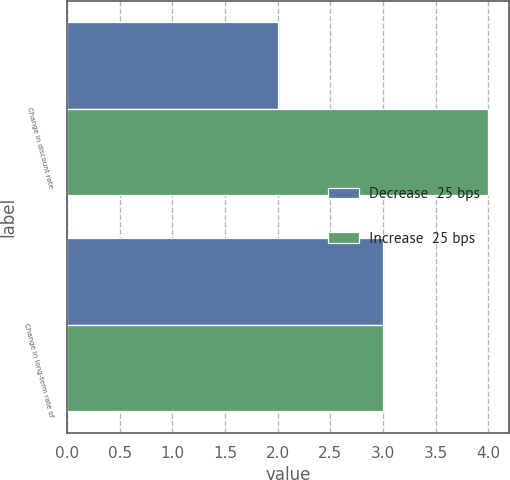<chart> <loc_0><loc_0><loc_500><loc_500><stacked_bar_chart><ecel><fcel>Change in discount rate<fcel>Change in long-term rate of<nl><fcel>Decrease  25 bps<fcel>2<fcel>3<nl><fcel>Increase  25 bps<fcel>4<fcel>3<nl></chart> 